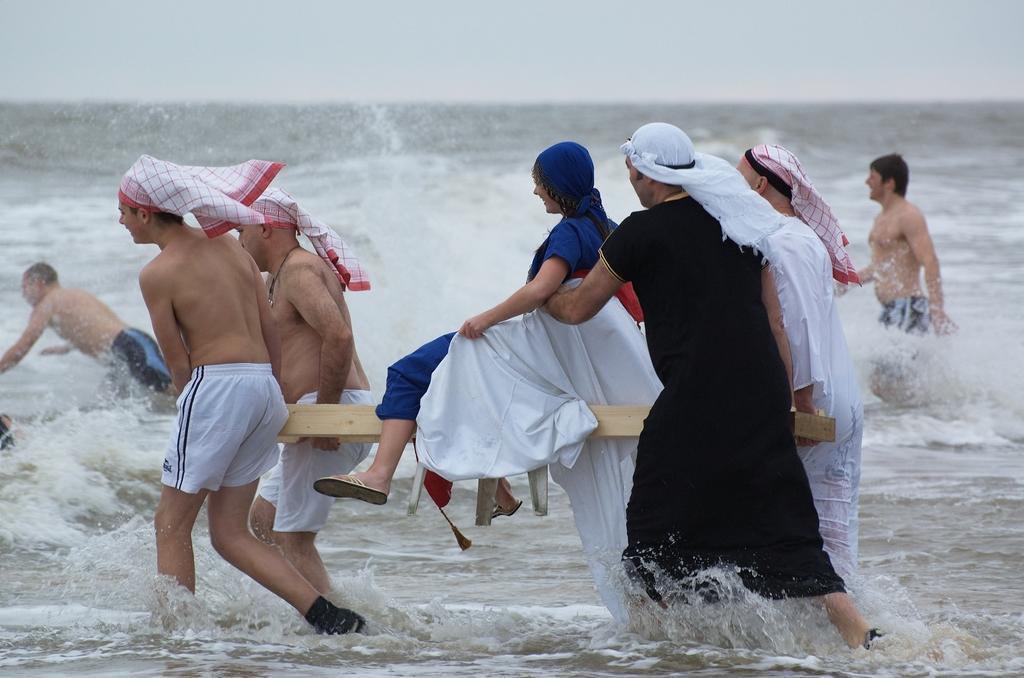Can you describe this image briefly? In this image I can see number of persons wearing white colored shorts and a person wearing black colored dress are standing on the water. I can see a wooden plank on which I can see a woman wearing blue colored dress is sitting. In the background I can see the water, few persons in the water and the sky. 